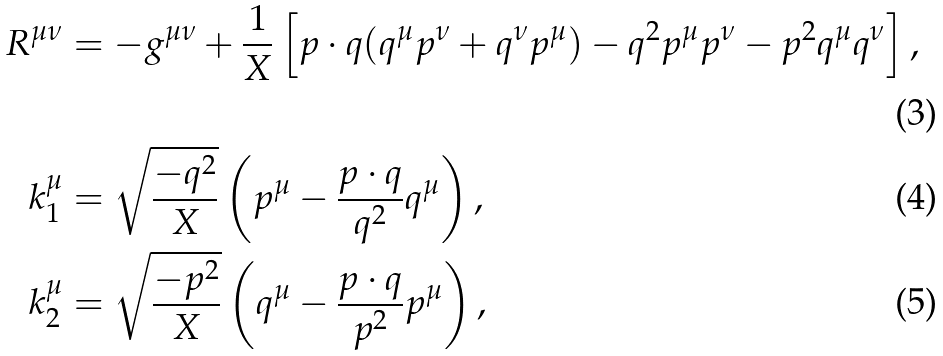Convert formula to latex. <formula><loc_0><loc_0><loc_500><loc_500>R ^ { \mu \nu } & = - g ^ { \mu \nu } + \frac { 1 } { X } \left [ p \cdot q ( q ^ { \mu } p ^ { \nu } + q ^ { \nu } p ^ { \mu } ) - q ^ { 2 } p ^ { \mu } p ^ { \nu } - p ^ { 2 } q ^ { \mu } q ^ { \nu } \right ] , \\ k _ { 1 } ^ { \mu } & = \sqrt { \frac { - q ^ { 2 } } { X } } \left ( p ^ { \mu } - \frac { p \cdot q } { q ^ { 2 } } q ^ { \mu } \right ) , \\ k _ { 2 } ^ { \mu } & = \sqrt { \frac { - p ^ { 2 } } { X } } \left ( q ^ { \mu } - \frac { p \cdot q } { p ^ { 2 } } p ^ { \mu } \right ) ,</formula> 